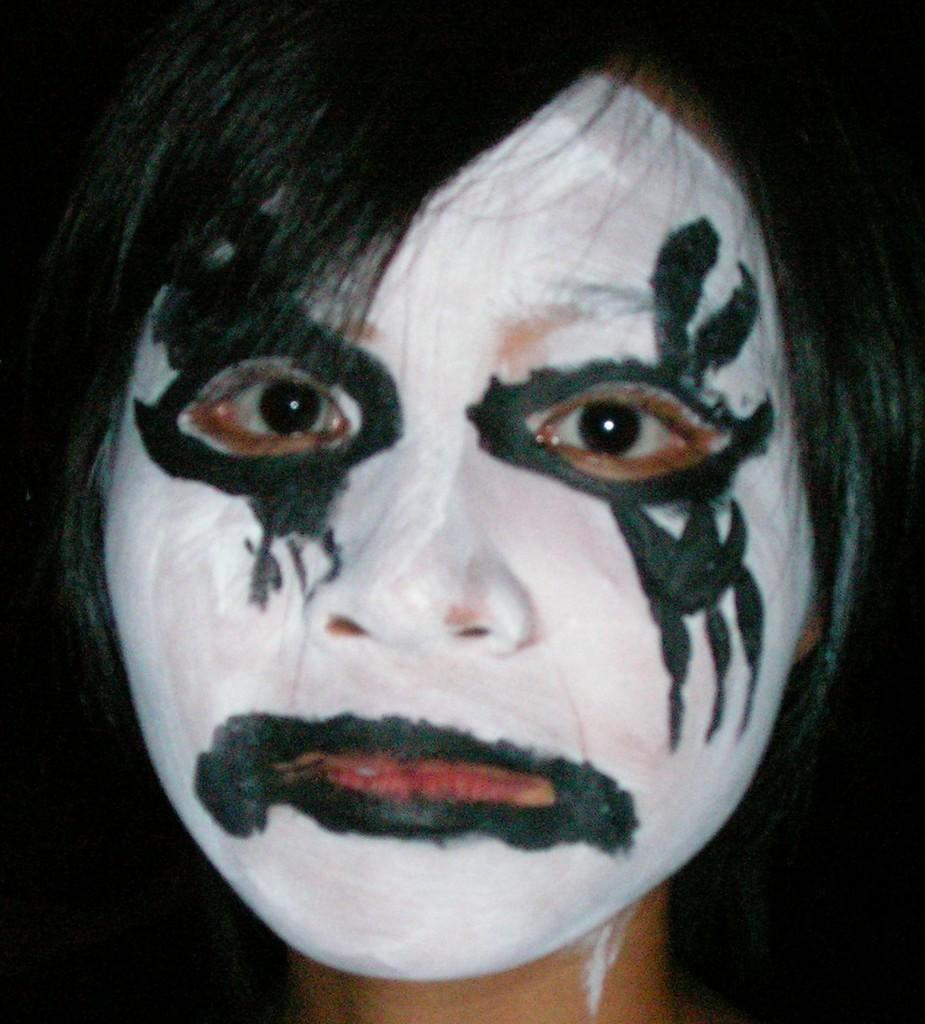What is the main subject of the image? The main subject of the image is a woman's face. What is on the woman's face in the image? There is a painting on the woman's face in the image. How would you describe the overall appearance of the image? The background of the image is dark. What time of day is depicted in the image? The provided facts do not mention the time of day, so it cannot be determined from the image. What type of board is visible in the image? There is no board present in the image. 